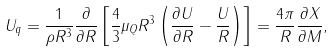Convert formula to latex. <formula><loc_0><loc_0><loc_500><loc_500>U _ { q } = \frac { 1 } { \rho R ^ { 3 } } \frac { \partial } { \partial R } \left [ \frac { 4 } { 3 } \mu _ { Q } R ^ { 3 } \left ( \frac { \partial U } { \partial R } - \frac { U } { R } \right ) \right ] = \frac { 4 \pi } { R } \frac { \partial X } { \partial M } ,</formula> 